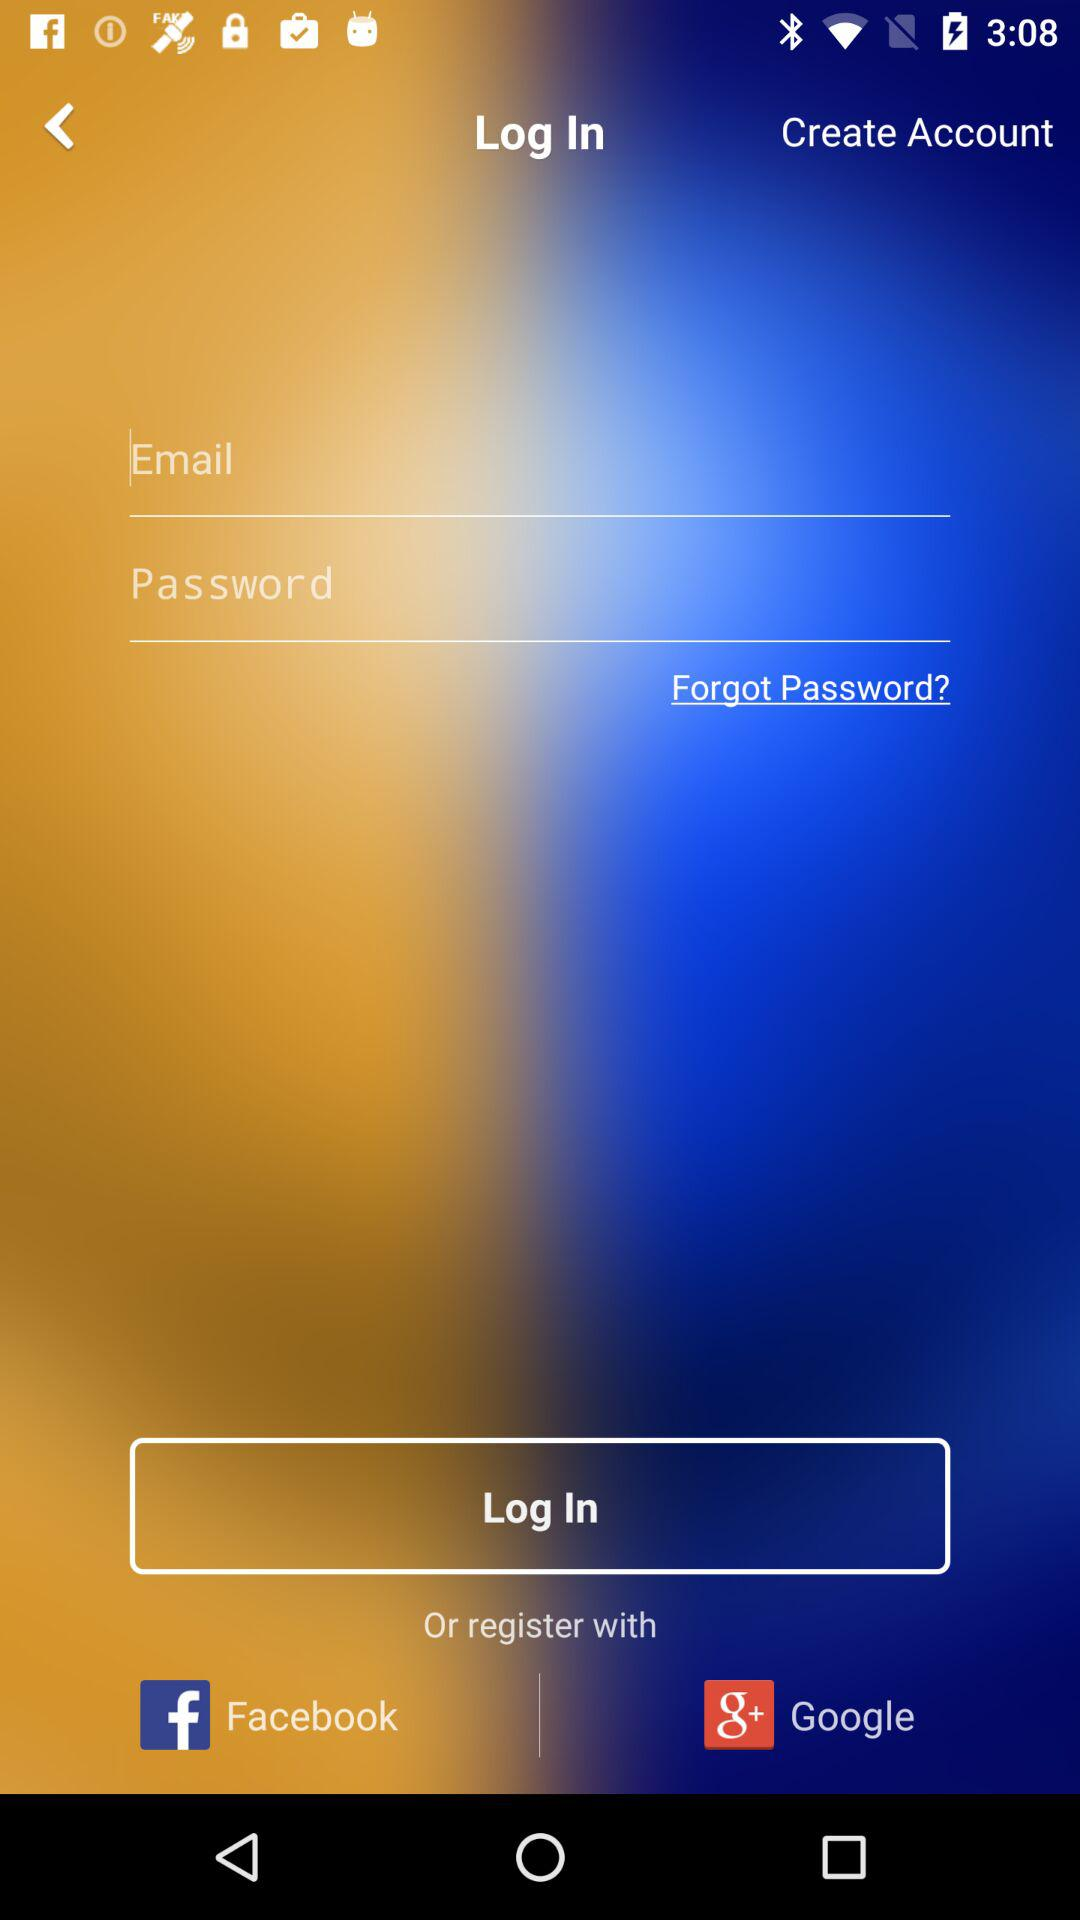What accounts can be used to login? The accounts are "Facebook" or "Google". 